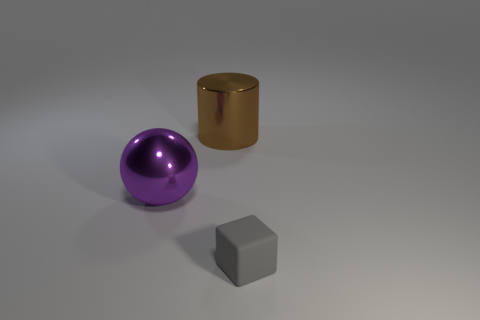Is there any other thing that has the same material as the tiny thing?
Offer a terse response. No. What is the cube made of?
Offer a very short reply. Rubber. The big shiny cylinder has what color?
Your response must be concise. Brown. Do the sphere and the shiny object right of the purple object have the same color?
Give a very brief answer. No. Are there any cylinders that have the same size as the purple metallic thing?
Provide a succinct answer. Yes. There is a thing in front of the purple shiny thing; what is it made of?
Provide a short and direct response. Rubber. Is the number of gray matte cubes left of the gray cube the same as the number of spheres that are in front of the large sphere?
Your answer should be compact. Yes. Does the thing to the right of the big brown thing have the same size as the thing that is behind the large metallic ball?
Your response must be concise. No. How many matte cubes are the same color as the small thing?
Ensure brevity in your answer.  0. Is the number of metal balls that are left of the small matte thing greater than the number of large blue shiny cylinders?
Provide a succinct answer. Yes. 